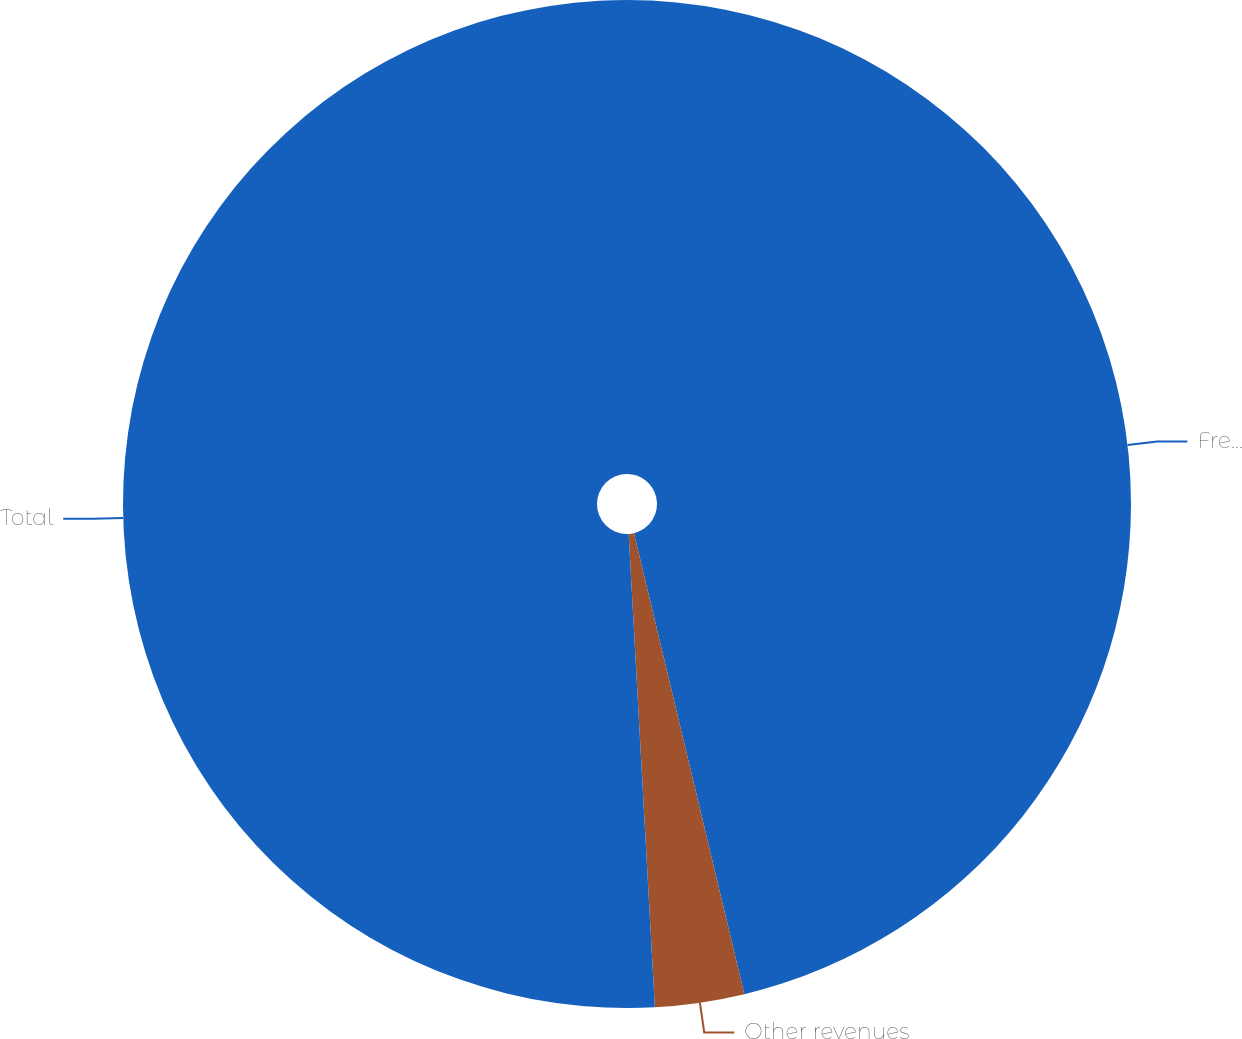Convert chart to OTSL. <chart><loc_0><loc_0><loc_500><loc_500><pie_chart><fcel>Freight revenues<fcel>Other revenues<fcel>Total<nl><fcel>46.26%<fcel>2.86%<fcel>50.88%<nl></chart> 